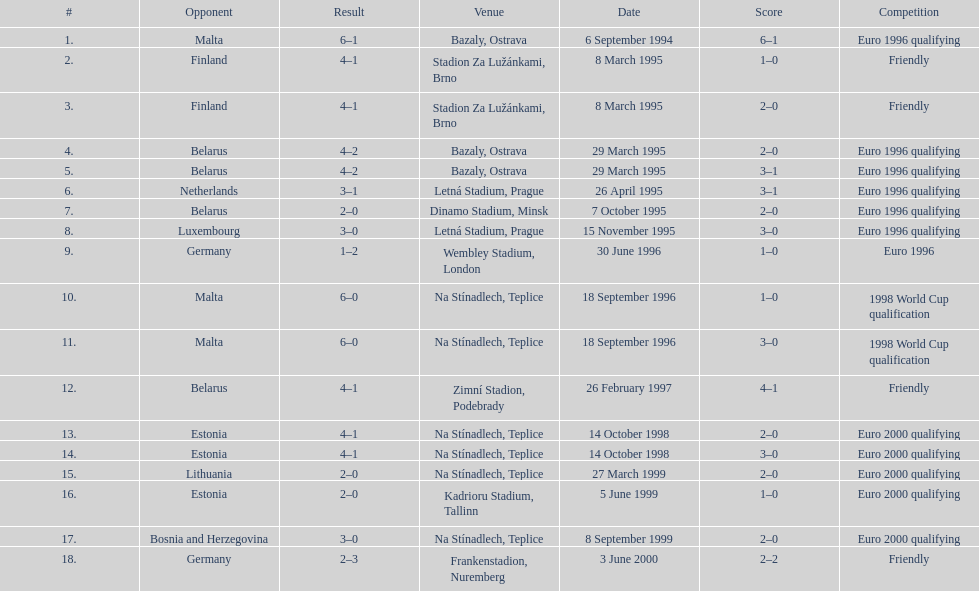What was the number of times czech republic played against germany? 2. 